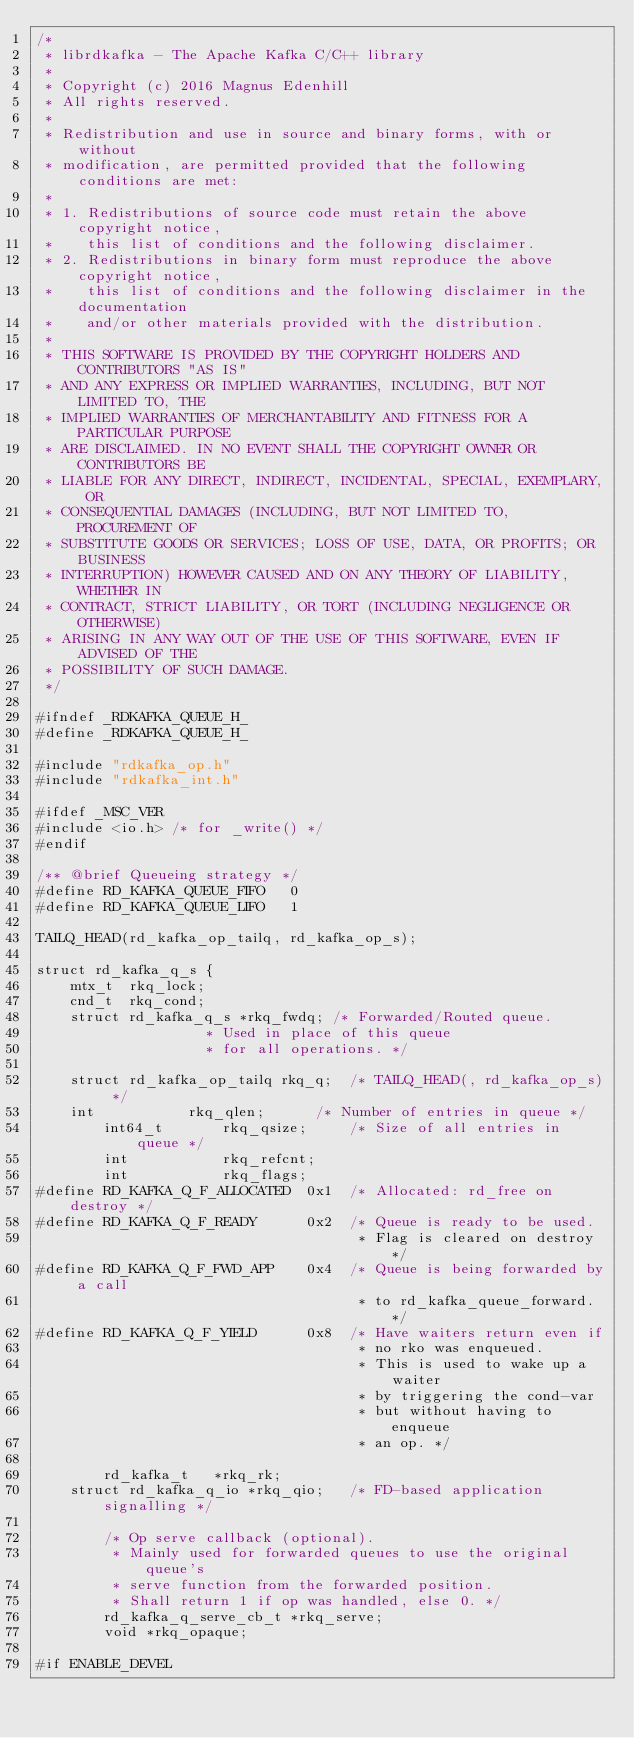Convert code to text. <code><loc_0><loc_0><loc_500><loc_500><_C_>/*
 * librdkafka - The Apache Kafka C/C++ library
 *
 * Copyright (c) 2016 Magnus Edenhill
 * All rights reserved.
 *
 * Redistribution and use in source and binary forms, with or without
 * modification, are permitted provided that the following conditions are met:
 *
 * 1. Redistributions of source code must retain the above copyright notice,
 *    this list of conditions and the following disclaimer.
 * 2. Redistributions in binary form must reproduce the above copyright notice,
 *    this list of conditions and the following disclaimer in the documentation
 *    and/or other materials provided with the distribution.
 *
 * THIS SOFTWARE IS PROVIDED BY THE COPYRIGHT HOLDERS AND CONTRIBUTORS "AS IS"
 * AND ANY EXPRESS OR IMPLIED WARRANTIES, INCLUDING, BUT NOT LIMITED TO, THE
 * IMPLIED WARRANTIES OF MERCHANTABILITY AND FITNESS FOR A PARTICULAR PURPOSE
 * ARE DISCLAIMED. IN NO EVENT SHALL THE COPYRIGHT OWNER OR CONTRIBUTORS BE
 * LIABLE FOR ANY DIRECT, INDIRECT, INCIDENTAL, SPECIAL, EXEMPLARY, OR
 * CONSEQUENTIAL DAMAGES (INCLUDING, BUT NOT LIMITED TO, PROCUREMENT OF
 * SUBSTITUTE GOODS OR SERVICES; LOSS OF USE, DATA, OR PROFITS; OR BUSINESS
 * INTERRUPTION) HOWEVER CAUSED AND ON ANY THEORY OF LIABILITY, WHETHER IN
 * CONTRACT, STRICT LIABILITY, OR TORT (INCLUDING NEGLIGENCE OR OTHERWISE)
 * ARISING IN ANY WAY OUT OF THE USE OF THIS SOFTWARE, EVEN IF ADVISED OF THE
 * POSSIBILITY OF SUCH DAMAGE.
 */

#ifndef _RDKAFKA_QUEUE_H_
#define _RDKAFKA_QUEUE_H_

#include "rdkafka_op.h"
#include "rdkafka_int.h"

#ifdef _MSC_VER
#include <io.h> /* for _write() */
#endif

/** @brief Queueing strategy */
#define RD_KAFKA_QUEUE_FIFO   0
#define RD_KAFKA_QUEUE_LIFO   1

TAILQ_HEAD(rd_kafka_op_tailq, rd_kafka_op_s);

struct rd_kafka_q_s {
	mtx_t  rkq_lock;
	cnd_t  rkq_cond;
	struct rd_kafka_q_s *rkq_fwdq; /* Forwarded/Routed queue.
					* Used in place of this queue
					* for all operations. */

	struct rd_kafka_op_tailq rkq_q;  /* TAILQ_HEAD(, rd_kafka_op_s) */
	int           rkq_qlen;      /* Number of entries in queue */
        int64_t       rkq_qsize;     /* Size of all entries in queue */
        int           rkq_refcnt;
        int           rkq_flags;
#define RD_KAFKA_Q_F_ALLOCATED  0x1  /* Allocated: rd_free on destroy */
#define RD_KAFKA_Q_F_READY      0x2  /* Queue is ready to be used.
                                      * Flag is cleared on destroy */
#define RD_KAFKA_Q_F_FWD_APP    0x4  /* Queue is being forwarded by a call
                                      * to rd_kafka_queue_forward. */
#define RD_KAFKA_Q_F_YIELD      0x8  /* Have waiters return even if
                                      * no rko was enqueued.
                                      * This is used to wake up a waiter
                                      * by triggering the cond-var
                                      * but without having to enqueue
                                      * an op. */

        rd_kafka_t   *rkq_rk;
	struct rd_kafka_q_io *rkq_qio;   /* FD-based application signalling */

        /* Op serve callback (optional).
         * Mainly used for forwarded queues to use the original queue's
         * serve function from the forwarded position.
         * Shall return 1 if op was handled, else 0. */
        rd_kafka_q_serve_cb_t *rkq_serve;
        void *rkq_opaque;

#if ENABLE_DEVEL</code> 